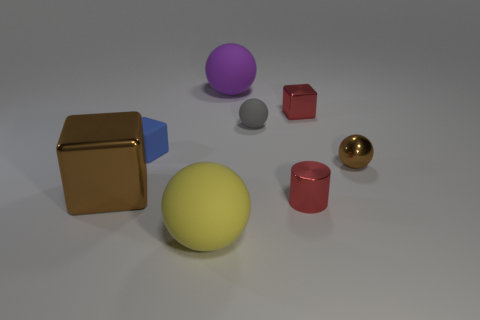Subtract all blue cubes. Subtract all red spheres. How many cubes are left? 2 Add 1 purple balls. How many objects exist? 9 Subtract all cylinders. How many objects are left? 7 Subtract all blue objects. Subtract all big purple rubber spheres. How many objects are left? 6 Add 5 large yellow rubber balls. How many large yellow rubber balls are left? 6 Add 8 purple things. How many purple things exist? 9 Subtract 0 blue cylinders. How many objects are left? 8 